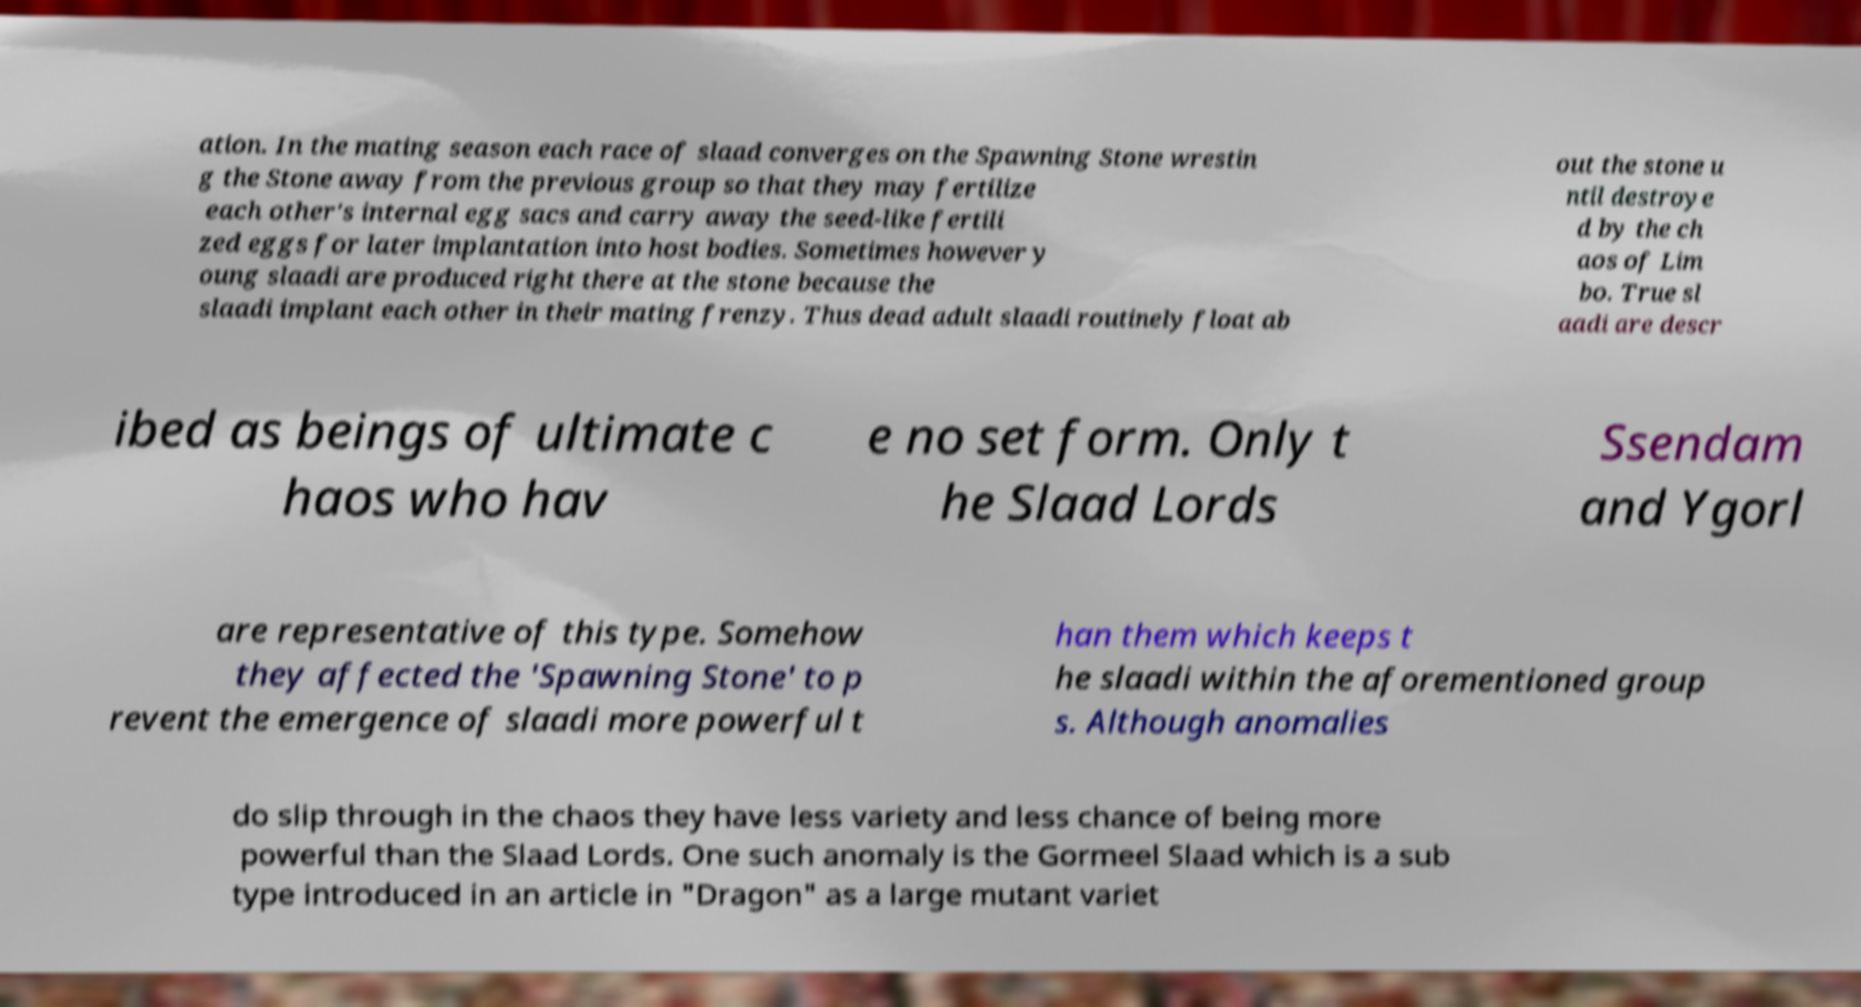Can you read and provide the text displayed in the image?This photo seems to have some interesting text. Can you extract and type it out for me? ation. In the mating season each race of slaad converges on the Spawning Stone wrestin g the Stone away from the previous group so that they may fertilize each other's internal egg sacs and carry away the seed-like fertili zed eggs for later implantation into host bodies. Sometimes however y oung slaadi are produced right there at the stone because the slaadi implant each other in their mating frenzy. Thus dead adult slaadi routinely float ab out the stone u ntil destroye d by the ch aos of Lim bo. True sl aadi are descr ibed as beings of ultimate c haos who hav e no set form. Only t he Slaad Lords Ssendam and Ygorl are representative of this type. Somehow they affected the 'Spawning Stone' to p revent the emergence of slaadi more powerful t han them which keeps t he slaadi within the aforementioned group s. Although anomalies do slip through in the chaos they have less variety and less chance of being more powerful than the Slaad Lords. One such anomaly is the Gormeel Slaad which is a sub type introduced in an article in "Dragon" as a large mutant variet 